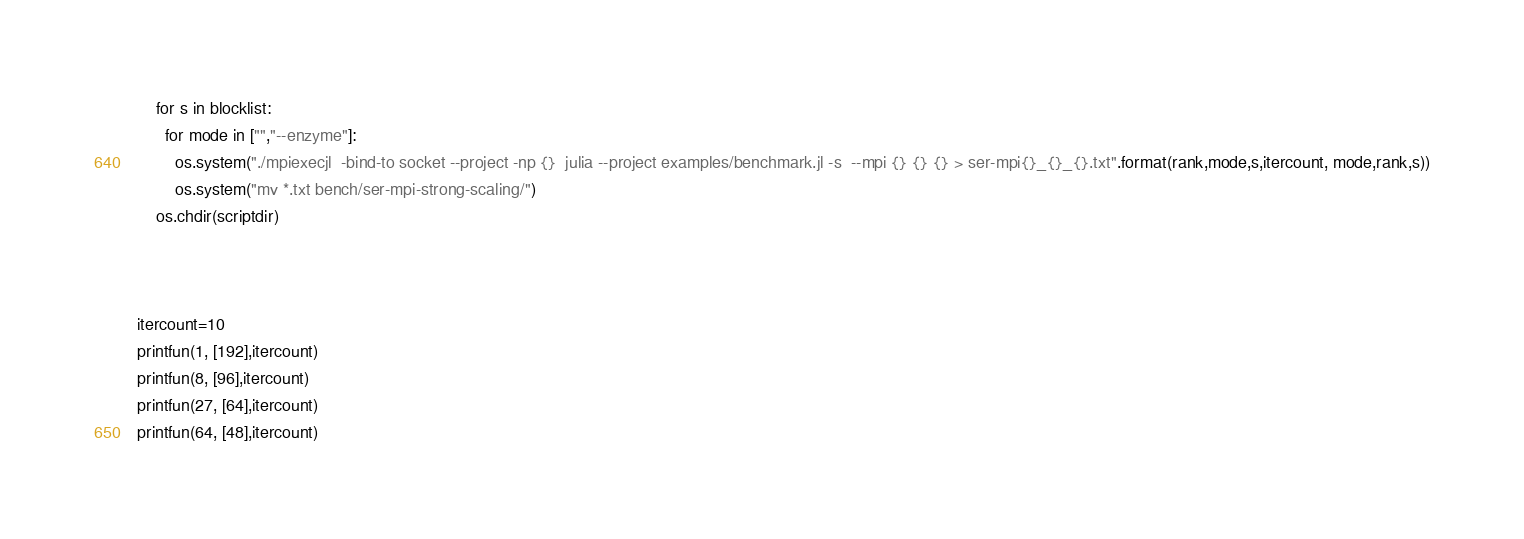Convert code to text. <code><loc_0><loc_0><loc_500><loc_500><_Python_>    for s in blocklist:
      for mode in ["","--enzyme"]:
        os.system("./mpiexecjl  -bind-to socket --project -np {}  julia --project examples/benchmark.jl -s  --mpi {} {} {} > ser-mpi{}_{}_{}.txt".format(rank,mode,s,itercount, mode,rank,s))
        os.system("mv *.txt bench/ser-mpi-strong-scaling/")
    os.chdir(scriptdir)



itercount=10
printfun(1, [192],itercount)
printfun(8, [96],itercount)
printfun(27, [64],itercount)
printfun(64, [48],itercount)
</code> 